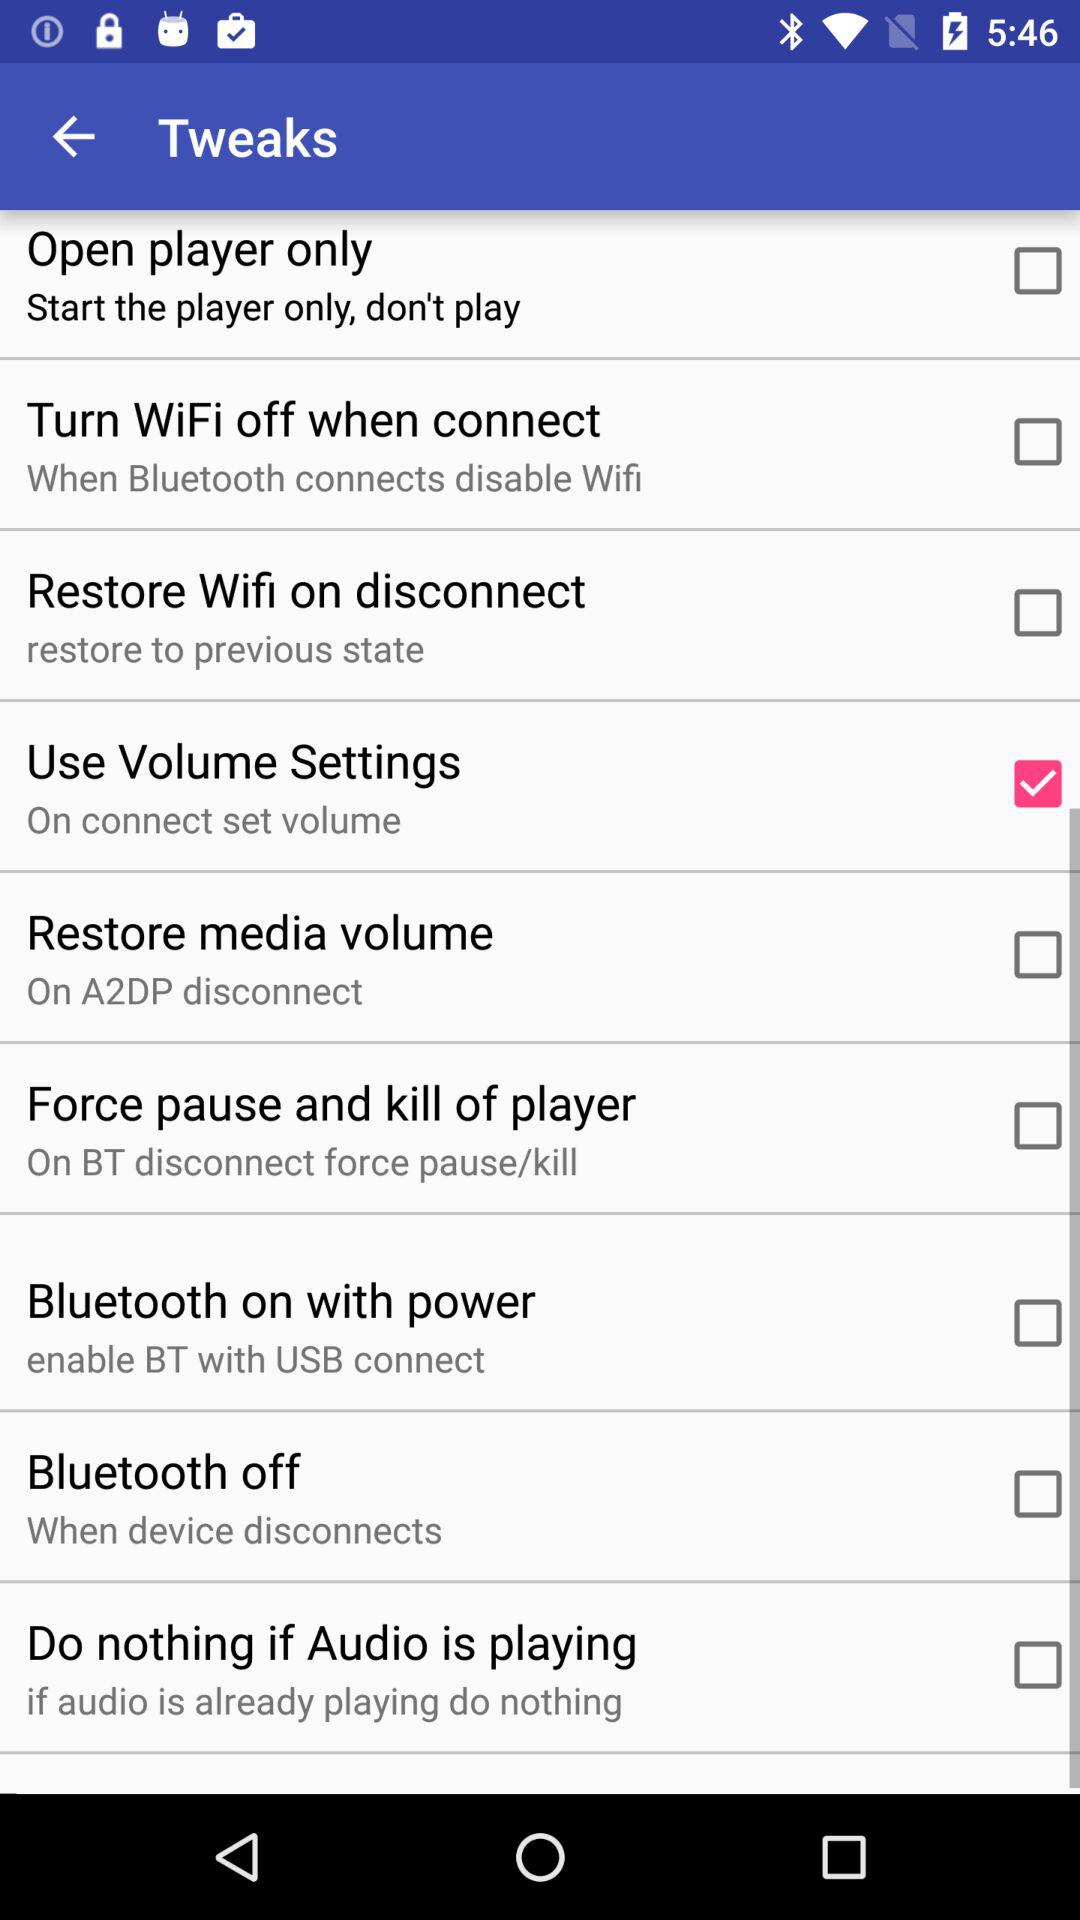What is the level of the volume?
When the provided information is insufficient, respond with <no answer>. <no answer> 